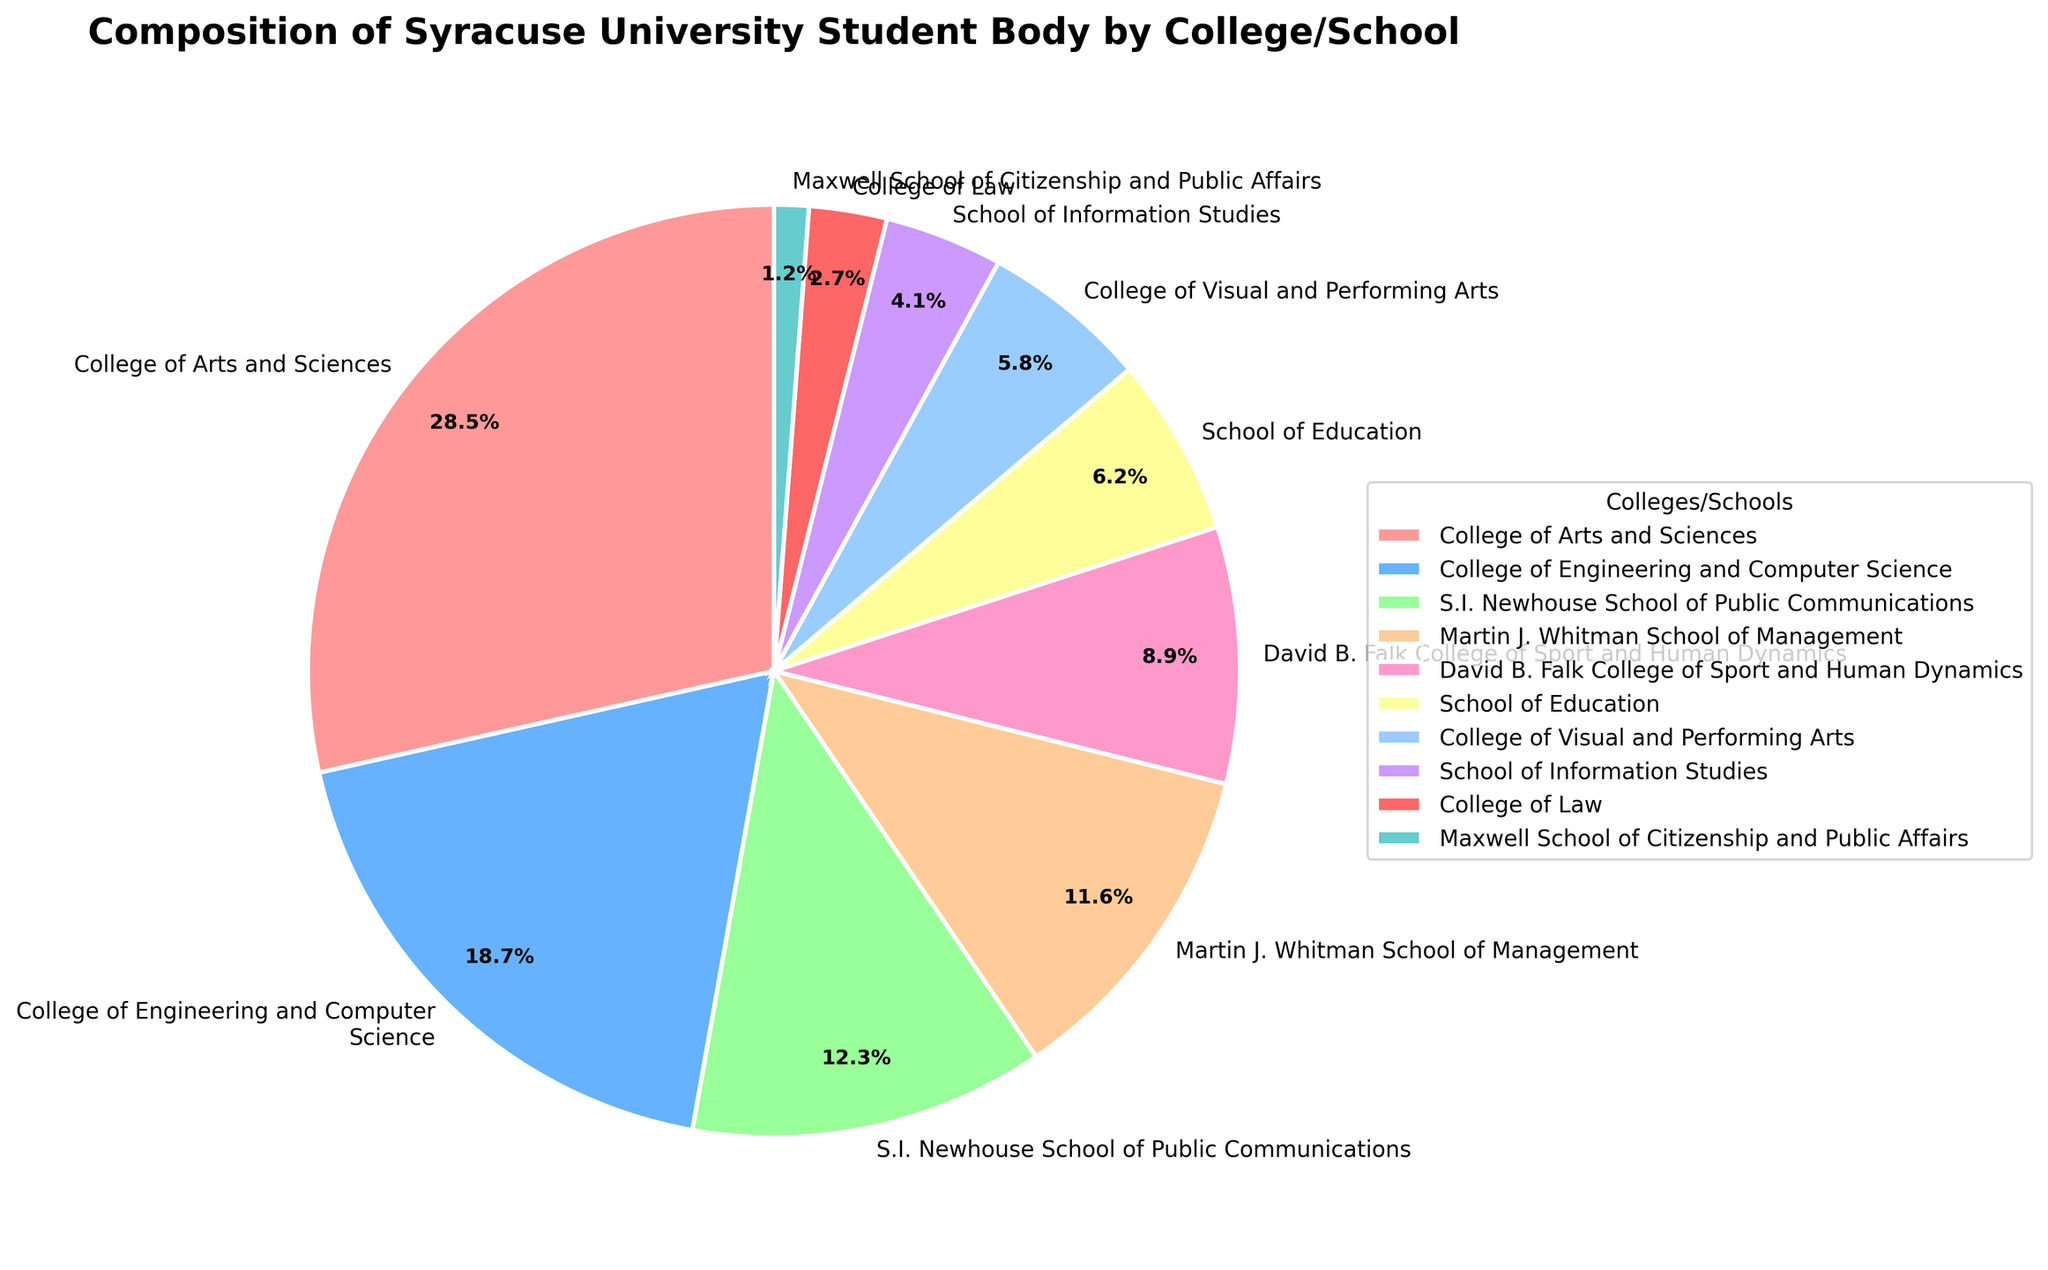Which college/school has the largest percentage of students? The pie chart shows the percentage of students in each college/school. The largest slice corresponds to the College of Arts and Sciences with 28.5%.
Answer: College of Arts and Sciences Which two colleges/schools combined account for over 40% of the student body? Adding the percentages of the two largest colleges/schools: College of Arts and Sciences (28.5%) and College of Engineering and Computer Science (18.7%). The sum is 47.2%, which is greater than 40%.
Answer: College of Arts and Sciences and College of Engineering and Computer Science How does the student body in the College of Engineering and Computer Science compare to the S.I. Newhouse School of Public Communications? The percentage of students in the College of Engineering and Computer Science is 18.7%, while the S.I. Newhouse School of Public Communications has 12.3%. 18.7% is greater than 12.3%.
Answer: The College of Engineering and Computer Science has a larger percentage What is the difference in student body percentage between David B. Falk College of Sport and Human Dynamics and the School of Education? Subtract the percentage of the School of Education (6.2%) from that of David B. Falk College of Sport and Human Dynamics (8.9%). The difference is 2.7%.
Answer: 2.7% Which college/school has the smallest percentage of students and what color represents it in the chart? By identifying the smallest slice of the pie chart, the College of Law is seen to have the smallest percentage of 2.7%. Its color can be identified in the legend.
Answer: College of Law and color (identify the color if known) What is the combined percentage of the School of Information Studies and College of Visual and Performing Arts? Adding the percentages of the School of Information Studies (4.1%) and College of Visual and Performing Arts (5.8%) results in 9.9%.
Answer: 9.9% Among the non-stem, non-management schools (Arts and Sciences, Public Communications, Sport and Human Dynamics, Education, Visual and Performing Arts, Information Studies, Law, Citizenship and Public Affairs), which has the highest percentage and what is that percentage? Compare the percentages of non-STEM & non-management schools: College of Arts and Sciences has the highest with 28.5%.
Answer: College of Arts and Sciences, 28.5% By how much does the percentage of students in the Martin J. Whitman School of Management exceed that in the Maxwell School of Citizenship and Public Affairs? Subtract the percentage of the Maxwell School of Citizenship and Public Affairs (1.2%) from that of the Martin J. Whitman School of Management (11.6%). The difference is 10.4%.
Answer: 10.4% What is the total percentage of students in colleges/schools other than the College of Arts and Sciences, and is it more or less than 70%? Subtract the percentage of the College of Arts and Sciences (28.5%) from 100%. The remaining percentage is 71.5%, which is greater than 70%.
Answer: 71.5%, more 